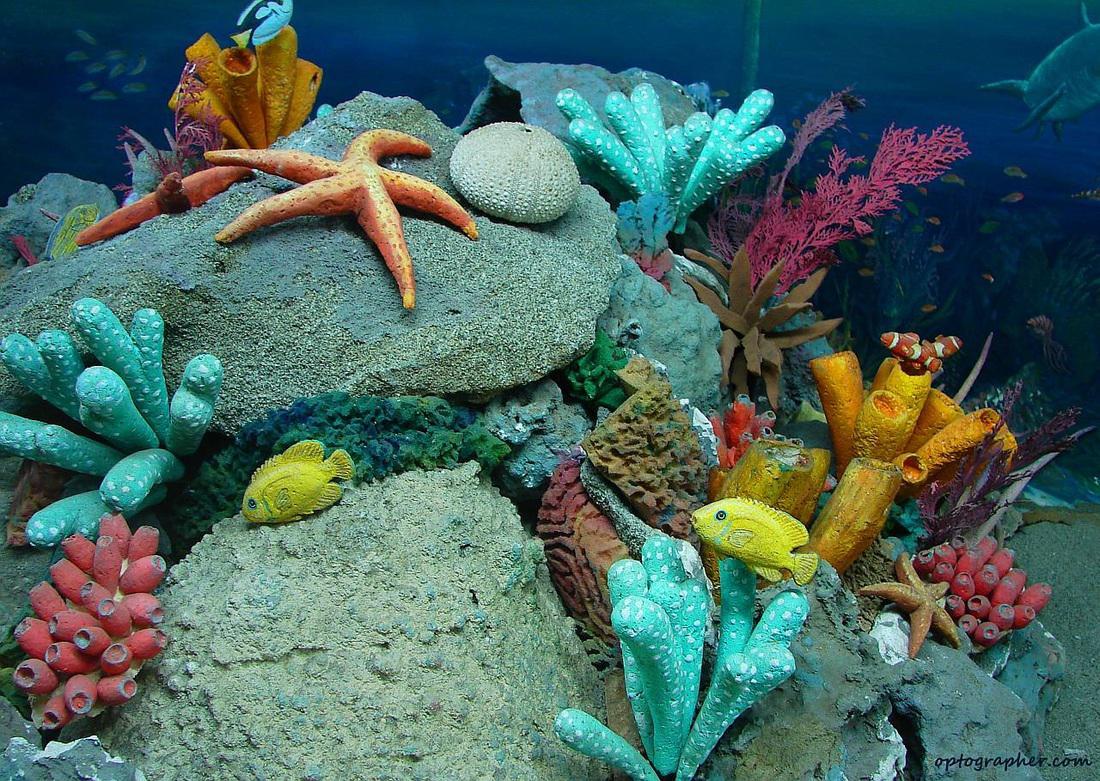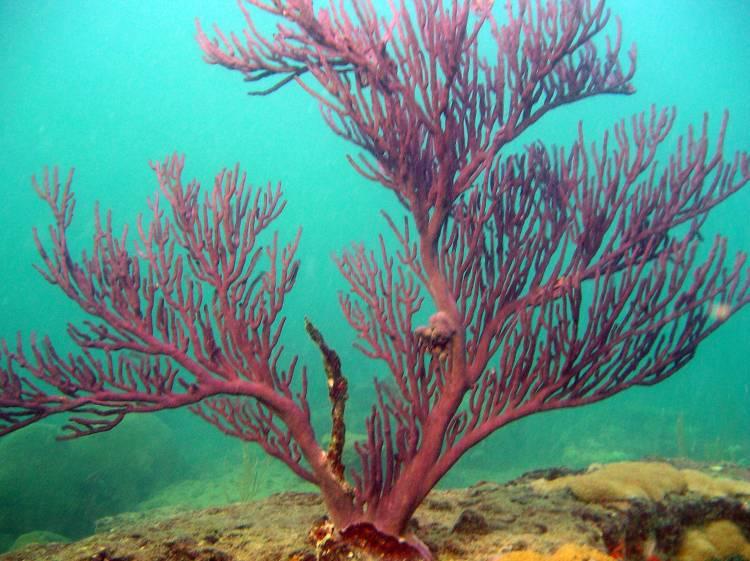The first image is the image on the left, the second image is the image on the right. Analyze the images presented: Is the assertion "One of the images shows exactly one orange and white fish next to an urchin." valid? Answer yes or no. No. The first image is the image on the left, the second image is the image on the right. Analyze the images presented: Is the assertion "There is a clownfish somewhere in the pair." valid? Answer yes or no. No. 